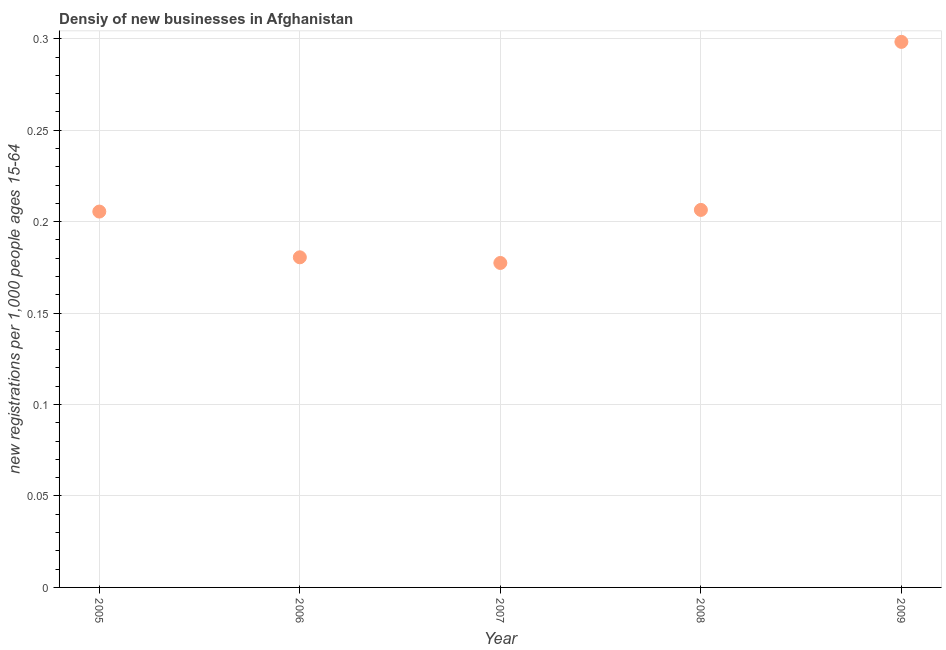What is the density of new business in 2006?
Your answer should be compact. 0.18. Across all years, what is the maximum density of new business?
Offer a very short reply. 0.3. Across all years, what is the minimum density of new business?
Offer a very short reply. 0.18. In which year was the density of new business minimum?
Your answer should be compact. 2007. What is the sum of the density of new business?
Provide a succinct answer. 1.07. What is the difference between the density of new business in 2005 and 2007?
Keep it short and to the point. 0.03. What is the average density of new business per year?
Keep it short and to the point. 0.21. What is the median density of new business?
Offer a terse response. 0.21. In how many years, is the density of new business greater than 0.23 ?
Offer a terse response. 1. Do a majority of the years between 2009 and 2008 (inclusive) have density of new business greater than 0.09 ?
Keep it short and to the point. No. What is the ratio of the density of new business in 2008 to that in 2009?
Give a very brief answer. 0.69. Is the density of new business in 2005 less than that in 2008?
Your answer should be compact. Yes. What is the difference between the highest and the second highest density of new business?
Provide a short and direct response. 0.09. What is the difference between the highest and the lowest density of new business?
Make the answer very short. 0.12. Does the density of new business monotonically increase over the years?
Provide a succinct answer. No. How many years are there in the graph?
Provide a short and direct response. 5. What is the difference between two consecutive major ticks on the Y-axis?
Provide a succinct answer. 0.05. Does the graph contain grids?
Provide a succinct answer. Yes. What is the title of the graph?
Offer a terse response. Densiy of new businesses in Afghanistan. What is the label or title of the X-axis?
Your answer should be very brief. Year. What is the label or title of the Y-axis?
Keep it short and to the point. New registrations per 1,0 people ages 15-64. What is the new registrations per 1,000 people ages 15-64 in 2005?
Your answer should be very brief. 0.21. What is the new registrations per 1,000 people ages 15-64 in 2006?
Provide a short and direct response. 0.18. What is the new registrations per 1,000 people ages 15-64 in 2007?
Provide a short and direct response. 0.18. What is the new registrations per 1,000 people ages 15-64 in 2008?
Give a very brief answer. 0.21. What is the new registrations per 1,000 people ages 15-64 in 2009?
Offer a very short reply. 0.3. What is the difference between the new registrations per 1,000 people ages 15-64 in 2005 and 2006?
Provide a short and direct response. 0.03. What is the difference between the new registrations per 1,000 people ages 15-64 in 2005 and 2007?
Keep it short and to the point. 0.03. What is the difference between the new registrations per 1,000 people ages 15-64 in 2005 and 2008?
Your answer should be compact. -0. What is the difference between the new registrations per 1,000 people ages 15-64 in 2005 and 2009?
Keep it short and to the point. -0.09. What is the difference between the new registrations per 1,000 people ages 15-64 in 2006 and 2007?
Your response must be concise. 0. What is the difference between the new registrations per 1,000 people ages 15-64 in 2006 and 2008?
Make the answer very short. -0.03. What is the difference between the new registrations per 1,000 people ages 15-64 in 2006 and 2009?
Make the answer very short. -0.12. What is the difference between the new registrations per 1,000 people ages 15-64 in 2007 and 2008?
Make the answer very short. -0.03. What is the difference between the new registrations per 1,000 people ages 15-64 in 2007 and 2009?
Provide a short and direct response. -0.12. What is the difference between the new registrations per 1,000 people ages 15-64 in 2008 and 2009?
Provide a succinct answer. -0.09. What is the ratio of the new registrations per 1,000 people ages 15-64 in 2005 to that in 2006?
Your answer should be compact. 1.14. What is the ratio of the new registrations per 1,000 people ages 15-64 in 2005 to that in 2007?
Make the answer very short. 1.16. What is the ratio of the new registrations per 1,000 people ages 15-64 in 2005 to that in 2009?
Ensure brevity in your answer.  0.69. What is the ratio of the new registrations per 1,000 people ages 15-64 in 2006 to that in 2007?
Provide a succinct answer. 1.02. What is the ratio of the new registrations per 1,000 people ages 15-64 in 2006 to that in 2008?
Your answer should be very brief. 0.87. What is the ratio of the new registrations per 1,000 people ages 15-64 in 2006 to that in 2009?
Provide a short and direct response. 0.6. What is the ratio of the new registrations per 1,000 people ages 15-64 in 2007 to that in 2008?
Keep it short and to the point. 0.86. What is the ratio of the new registrations per 1,000 people ages 15-64 in 2007 to that in 2009?
Your response must be concise. 0.59. What is the ratio of the new registrations per 1,000 people ages 15-64 in 2008 to that in 2009?
Offer a terse response. 0.69. 